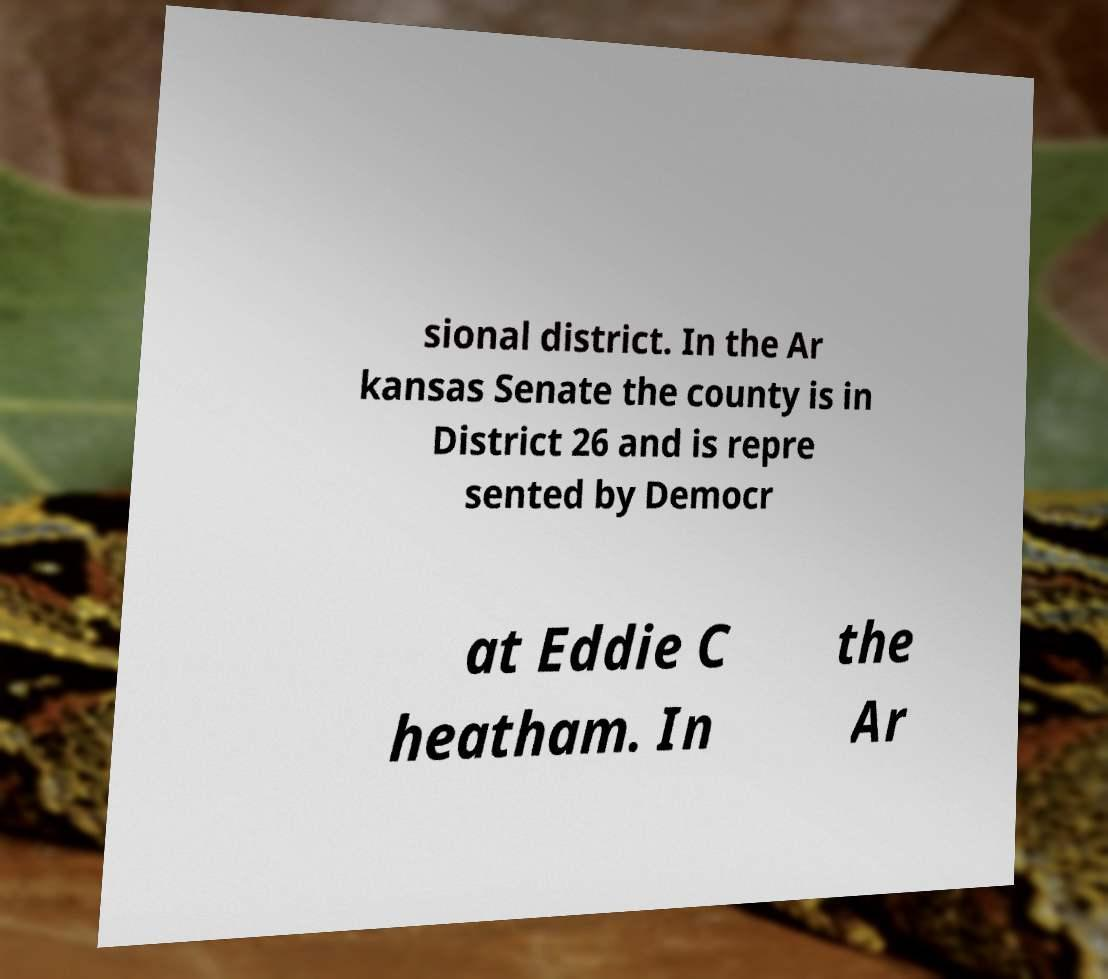Could you extract and type out the text from this image? sional district. In the Ar kansas Senate the county is in District 26 and is repre sented by Democr at Eddie C heatham. In the Ar 